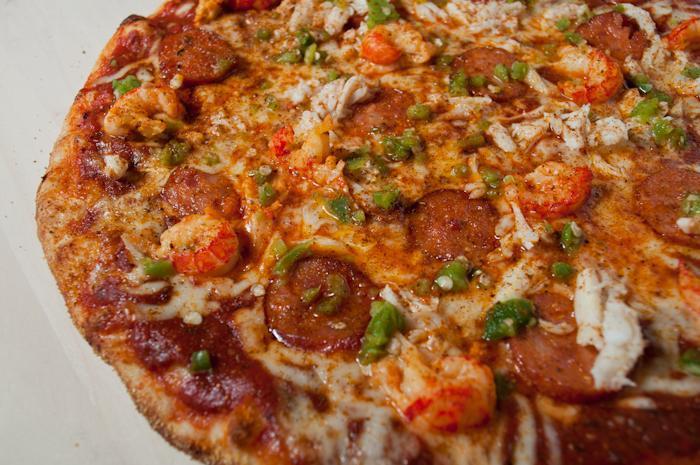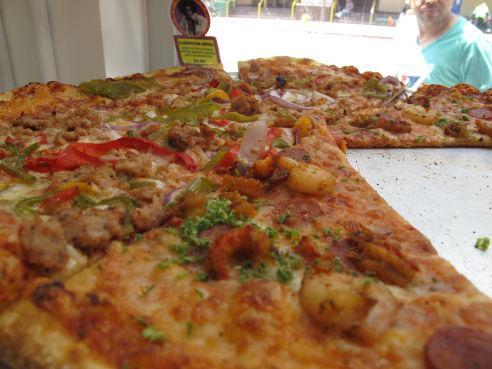The first image is the image on the left, the second image is the image on the right. Considering the images on both sides, is "One image shows an unsliced pizza, and the other image features less than an entire pizza but at least one slice." valid? Answer yes or no. Yes. 